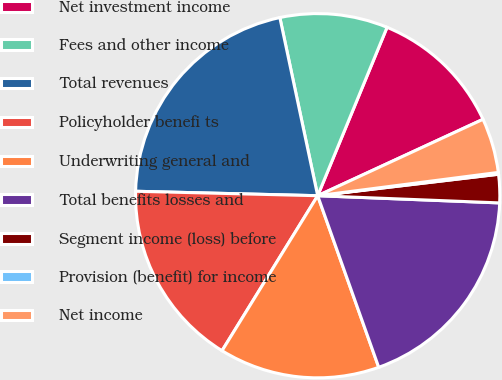Convert chart. <chart><loc_0><loc_0><loc_500><loc_500><pie_chart><fcel>Net investment income<fcel>Fees and other income<fcel>Total revenues<fcel>Policyholder benefi ts<fcel>Underwriting general and<fcel>Total benefits losses and<fcel>Segment income (loss) before<fcel>Provision (benefit) for income<fcel>Net income<nl><fcel>11.89%<fcel>9.55%<fcel>21.28%<fcel>16.59%<fcel>14.24%<fcel>18.93%<fcel>2.51%<fcel>0.16%<fcel>4.85%<nl></chart> 